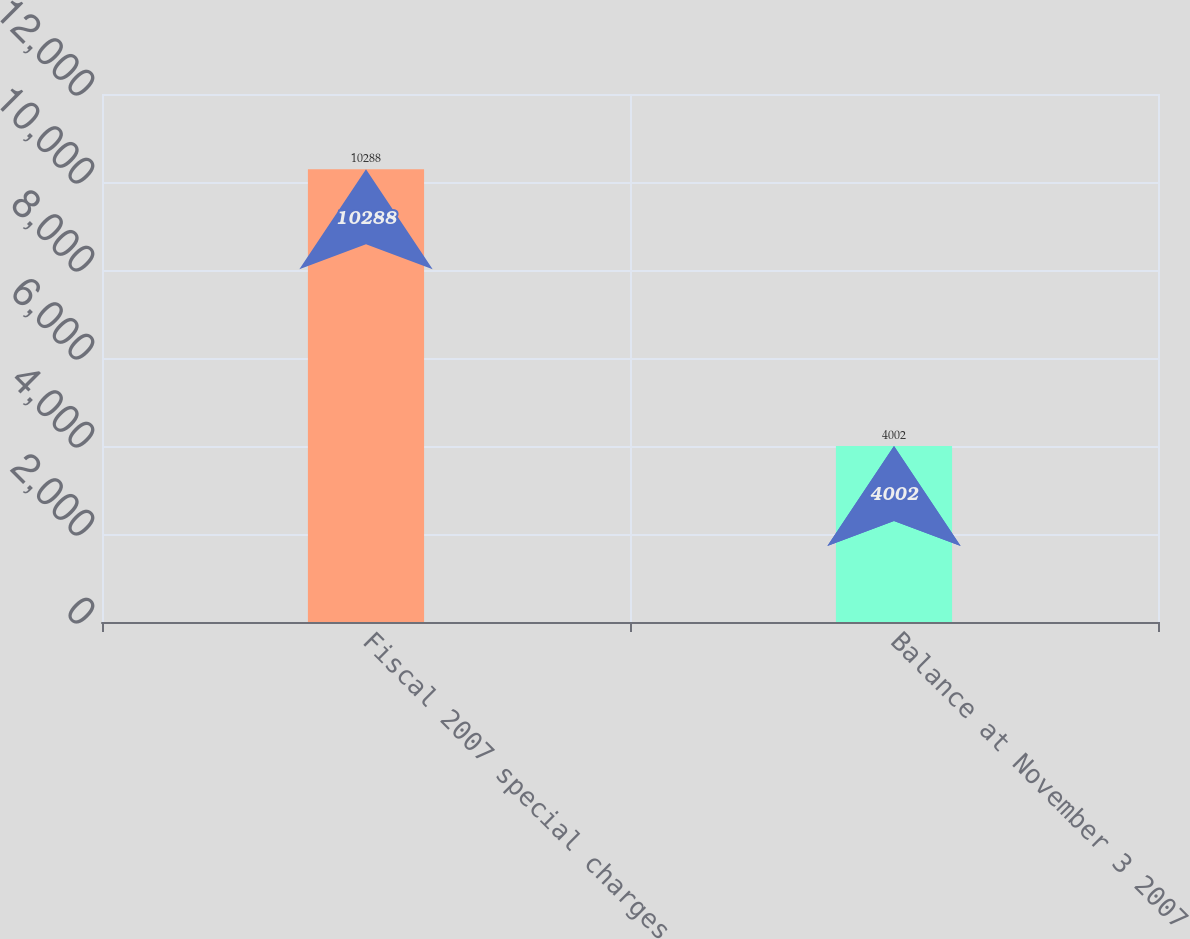<chart> <loc_0><loc_0><loc_500><loc_500><bar_chart><fcel>Fiscal 2007 special charges<fcel>Balance at November 3 2007<nl><fcel>10288<fcel>4002<nl></chart> 